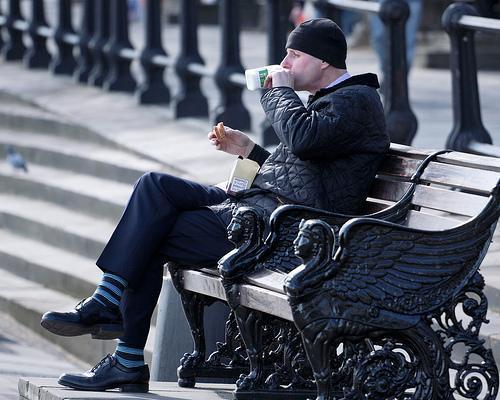How many people on the bench?
Give a very brief answer. 1. 